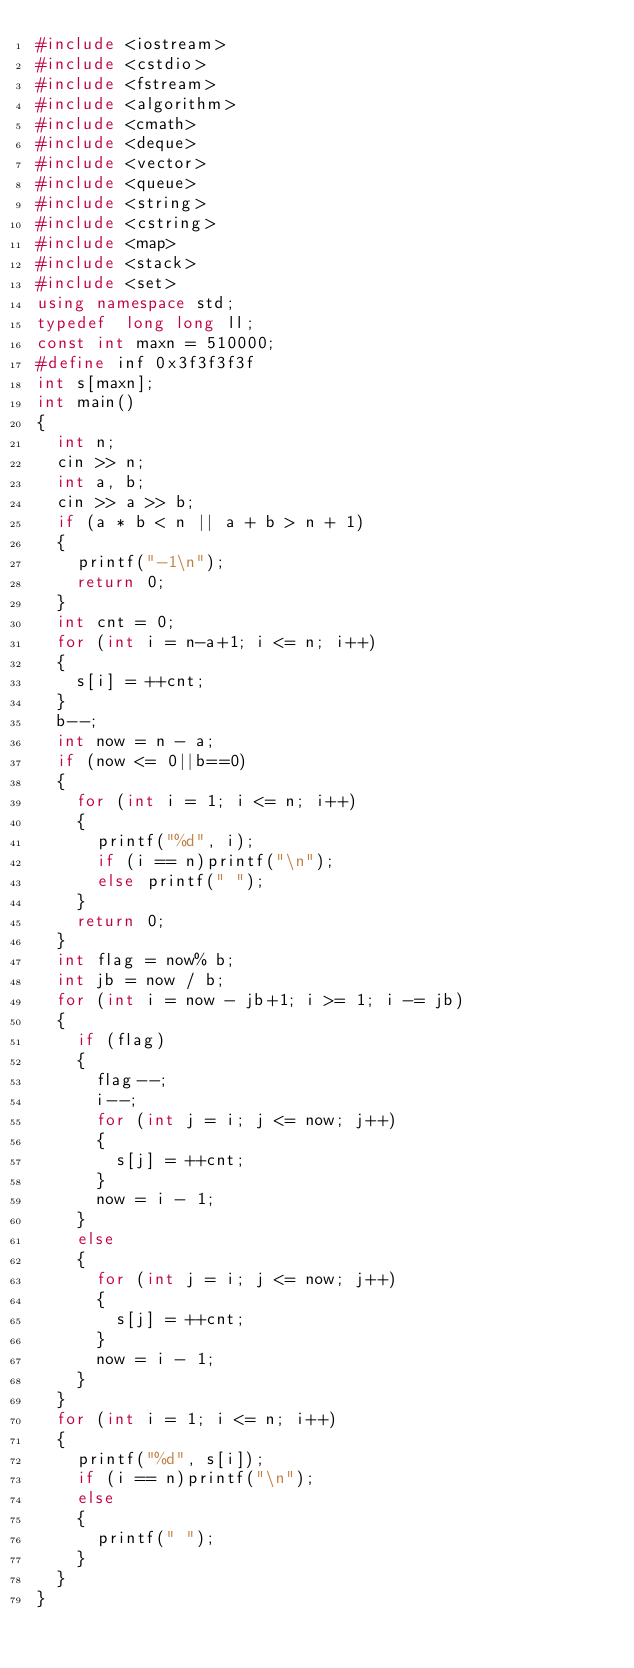Convert code to text. <code><loc_0><loc_0><loc_500><loc_500><_C++_>#include <iostream> 
#include <cstdio> 
#include <fstream> 
#include <algorithm> 
#include <cmath> 
#include <deque> 
#include <vector> 
#include <queue> 
#include <string> 
#include <cstring> 
#include <map> 
#include <stack> 
#include <set> 
using namespace std;
typedef  long long ll;
const int maxn = 510000;
#define inf 0x3f3f3f3f
int s[maxn];
int main()
{
	int n;
	cin >> n;
	int a, b;
	cin >> a >> b;
	if (a * b < n || a + b > n + 1)
	{
		printf("-1\n");
		return 0;
	}
	int cnt = 0;
	for (int i = n-a+1; i <= n; i++)
	{
		s[i] = ++cnt;
	}
	b--;
	int now = n - a;
	if (now <= 0||b==0)
	{
		for (int i = 1; i <= n; i++)
		{
			printf("%d", i);
			if (i == n)printf("\n");
			else printf(" ");
		}
		return 0;
	}
	int flag = now% b;
	int jb = now / b;
	for (int i = now - jb+1; i >= 1; i -= jb)
	{
		if (flag)
		{
			flag--;
			i--;
			for (int j = i; j <= now; j++)
			{
				s[j] = ++cnt;
			}
			now = i - 1;
		}
		else
		{
			for (int j = i; j <= now; j++)
			{
				s[j] = ++cnt;
			}
			now = i - 1;
		}
	}
	for (int i = 1; i <= n; i++)
	{
		printf("%d", s[i]);
		if (i == n)printf("\n");
		else
		{
			printf(" ");
		}
	}
}</code> 